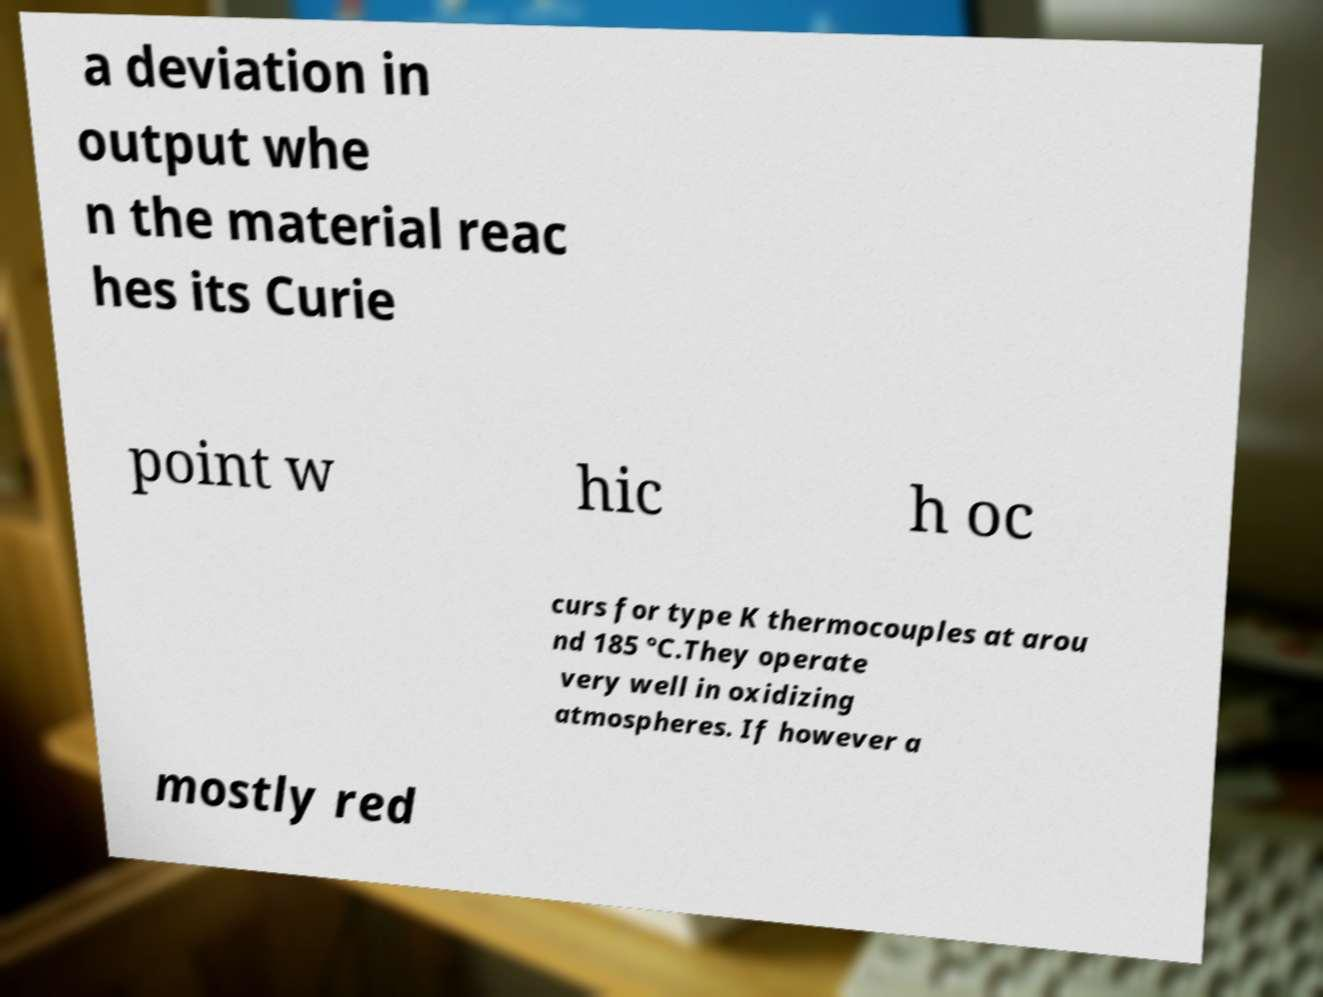Please read and relay the text visible in this image. What does it say? a deviation in output whe n the material reac hes its Curie point w hic h oc curs for type K thermocouples at arou nd 185 °C.They operate very well in oxidizing atmospheres. If however a mostly red 